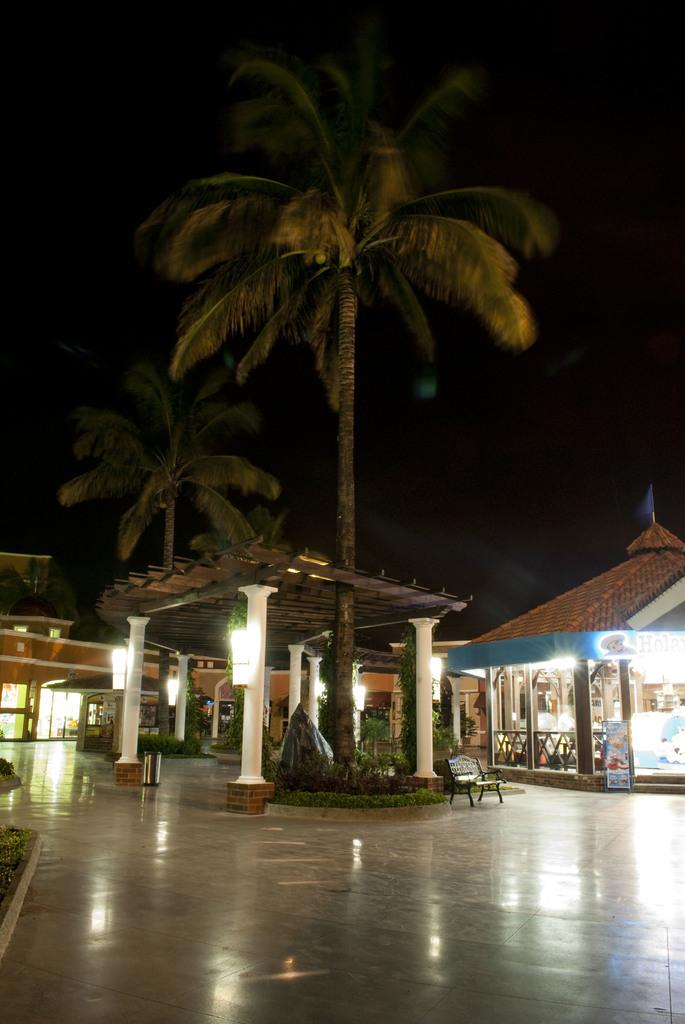What type of establishment is shown in the image? There is a resort in the image. What can be seen in the middle of the image? There is a roof in the middle of the image. What type of natural elements are present in the image? There are trees in the image. What type of seating is available near the roof? There is a bench beside the roof. What type of cord is used to hang the pear from the roof in the image? There is no pear or cord present in the image; it only features a resort, a roof, trees, and a bench. 